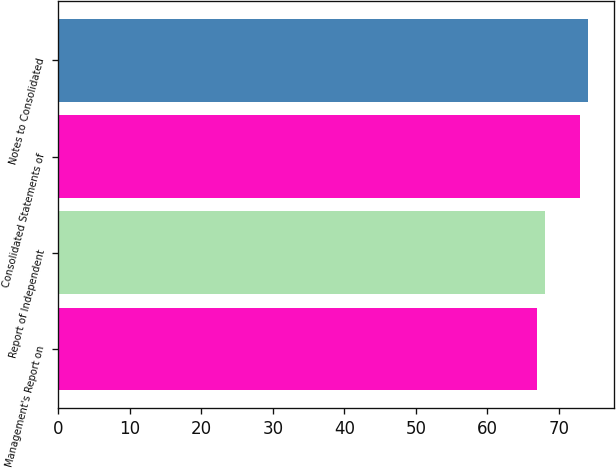Convert chart. <chart><loc_0><loc_0><loc_500><loc_500><bar_chart><fcel>Management's Report on<fcel>Report of Independent<fcel>Consolidated Statements of<fcel>Notes to Consolidated<nl><fcel>67<fcel>68<fcel>73<fcel>74<nl></chart> 